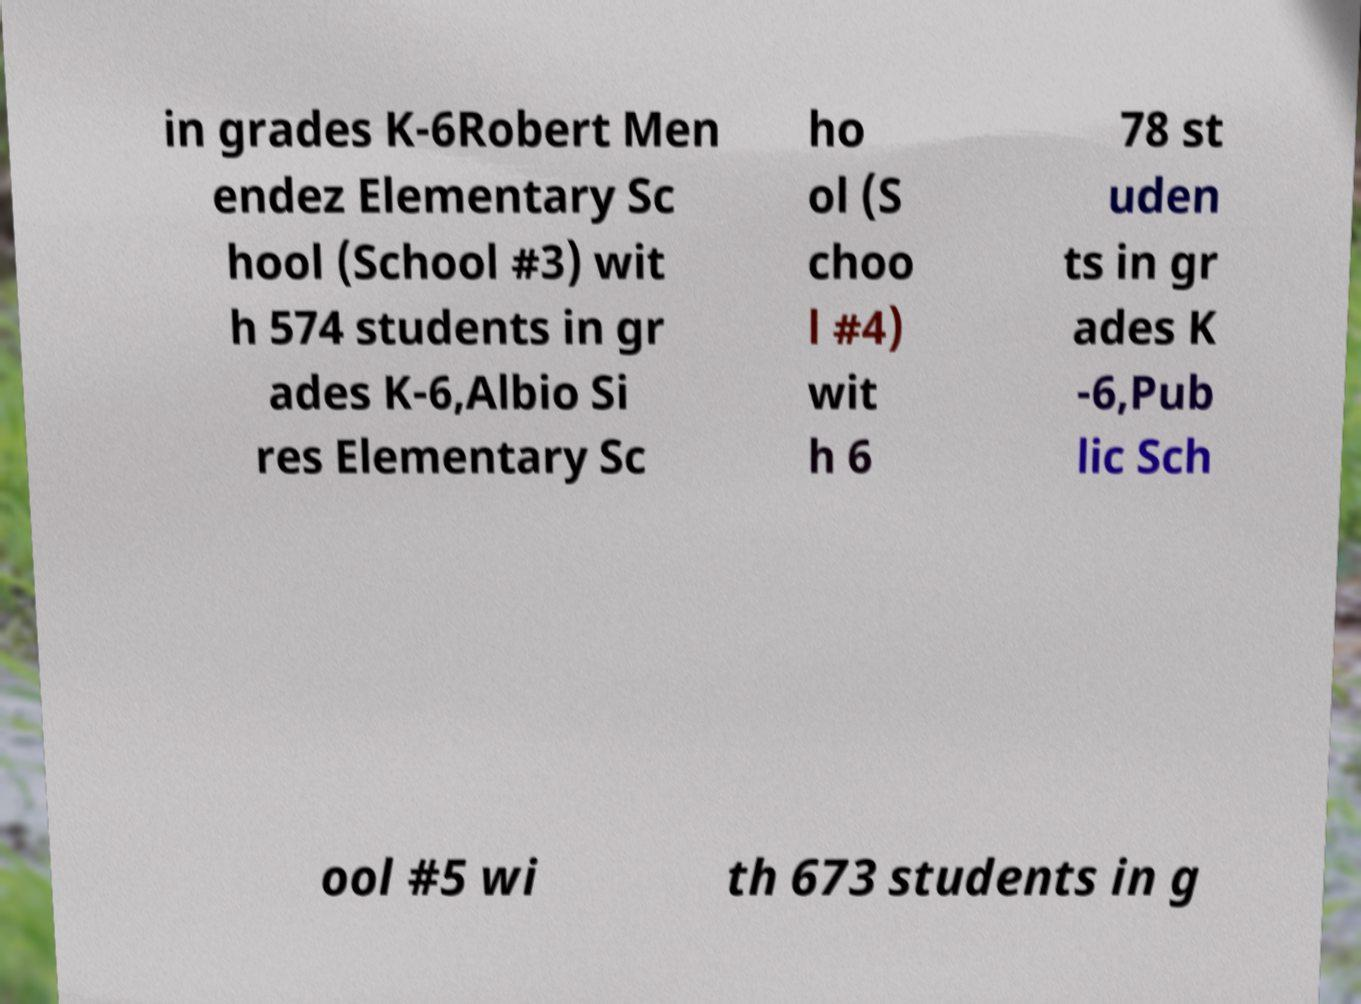Can you accurately transcribe the text from the provided image for me? in grades K-6Robert Men endez Elementary Sc hool (School #3) wit h 574 students in gr ades K-6,Albio Si res Elementary Sc ho ol (S choo l #4) wit h 6 78 st uden ts in gr ades K -6,Pub lic Sch ool #5 wi th 673 students in g 